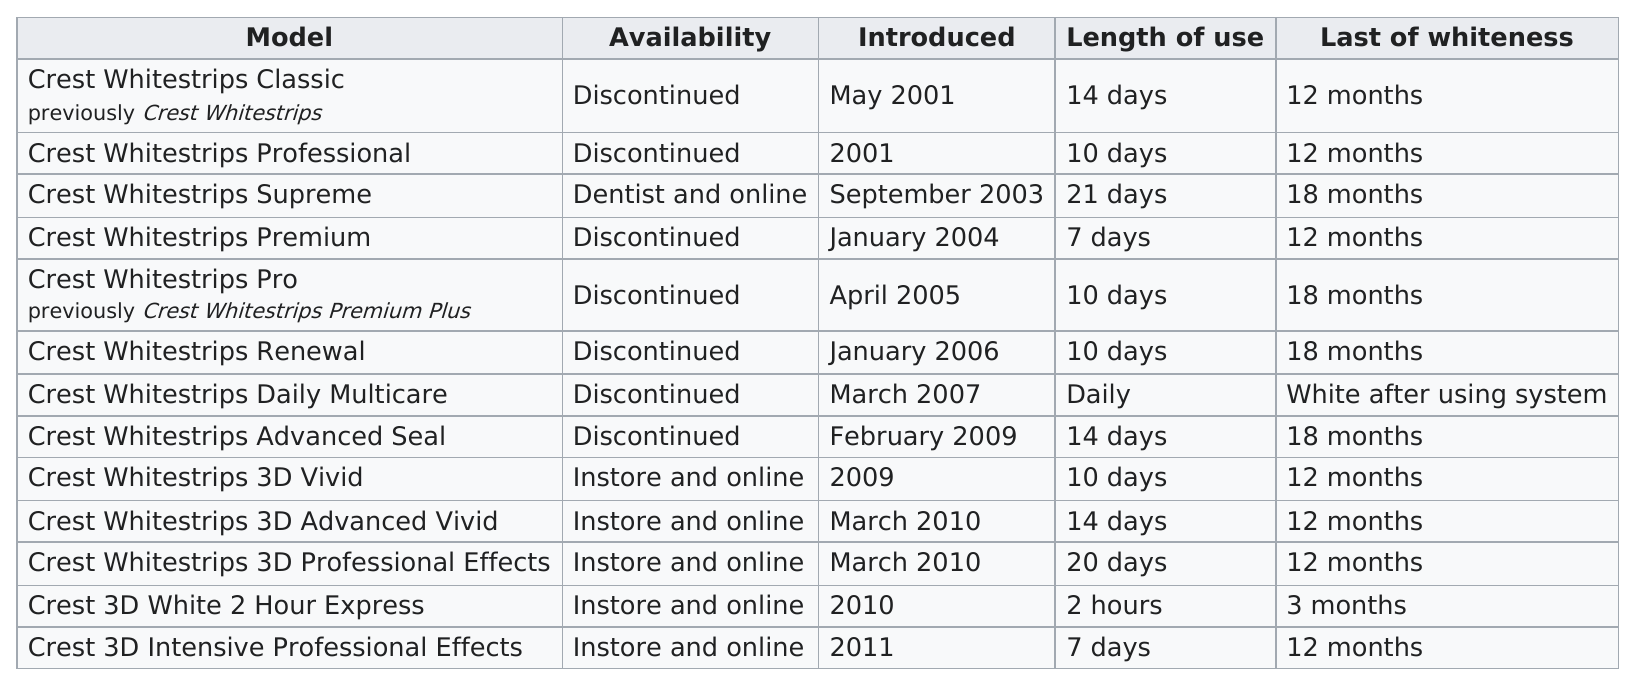Indicate a few pertinent items in this graphic. Can you please inform me of the number of products that provide 12 months of whiteness? Thank you. According to the data, two models require less than a week of use. In 2010, the number of products introduced was three. The question you have posed is difficult to interpret without additional context or clarification. Could you please provide more information or clarify your question? For 14 days, I use Crest White Strips Advanced Seal to maintain my white smile. 